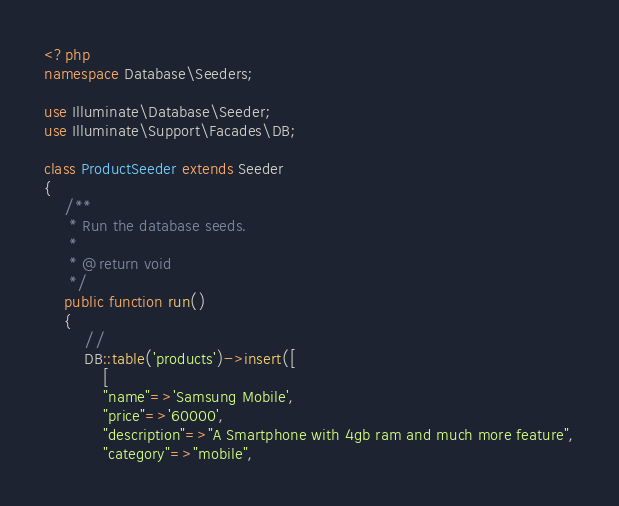Convert code to text. <code><loc_0><loc_0><loc_500><loc_500><_PHP_><?php
namespace Database\Seeders;

use Illuminate\Database\Seeder;
use Illuminate\Support\Facades\DB;

class ProductSeeder extends Seeder
{
    /**
     * Run the database seeds.
     *
     * @return void
     */
    public function run()
    {
        //
        DB::table('products')->insert([
            [
            "name"=>'Samsung Mobile',
            "price"=>'60000',
            "description"=>"A Smartphone with 4gb ram and much more feature",
            "category"=>"mobile",</code> 